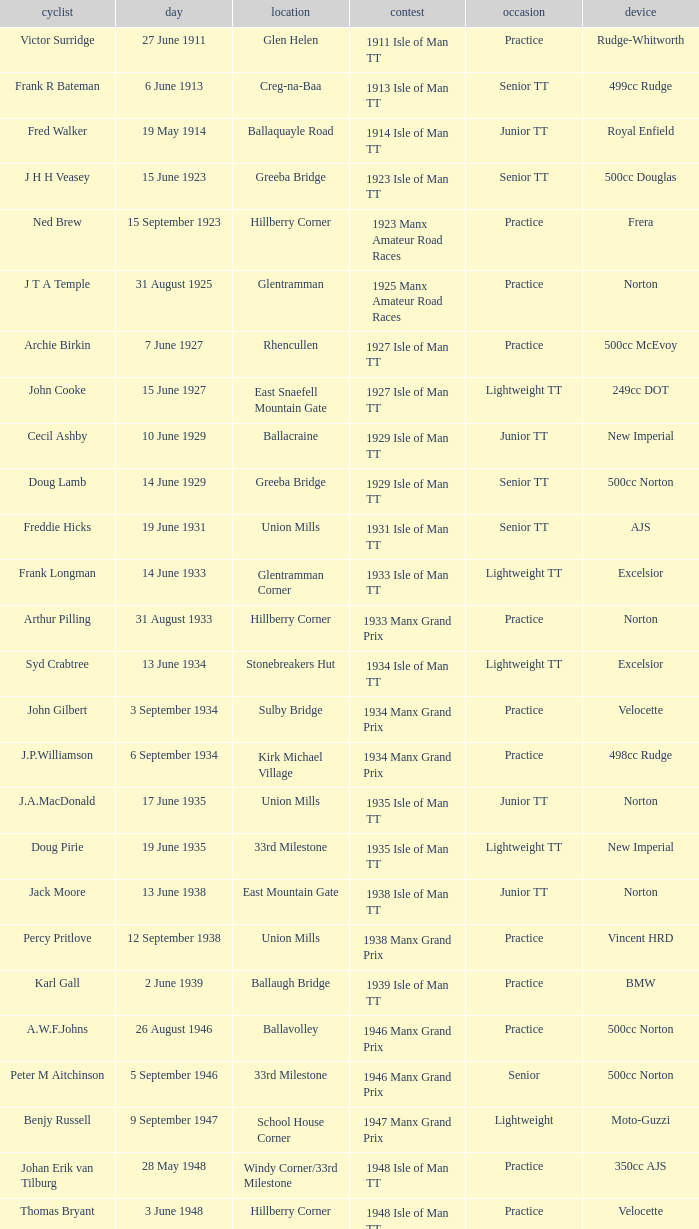What event was Rob Vine riding? Senior TT. 